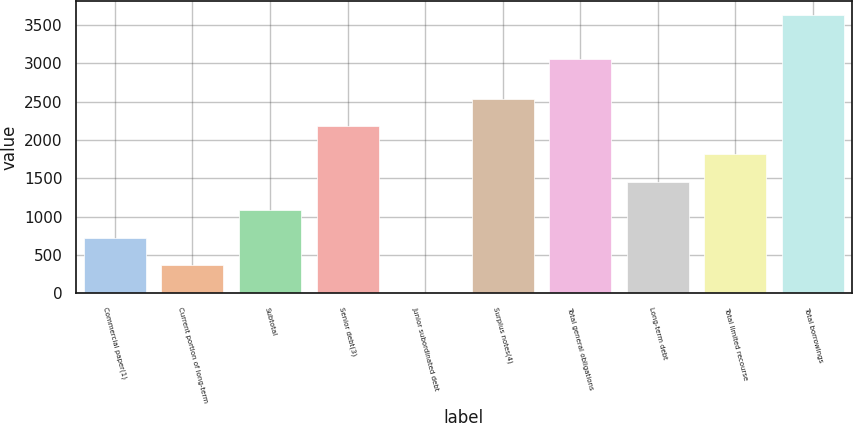Convert chart to OTSL. <chart><loc_0><loc_0><loc_500><loc_500><bar_chart><fcel>Commercial paper(1)<fcel>Current portion of long-term<fcel>Subtotal<fcel>Senior debt(3)<fcel>Junior subordinated debt<fcel>Surplus notes(4)<fcel>Total general obligations<fcel>Long-term debt<fcel>Total limited recourse<fcel>Total borrowings<nl><fcel>725.55<fcel>363.12<fcel>1087.98<fcel>2175.27<fcel>0.69<fcel>2537.7<fcel>3060<fcel>1450.41<fcel>1812.84<fcel>3625<nl></chart> 